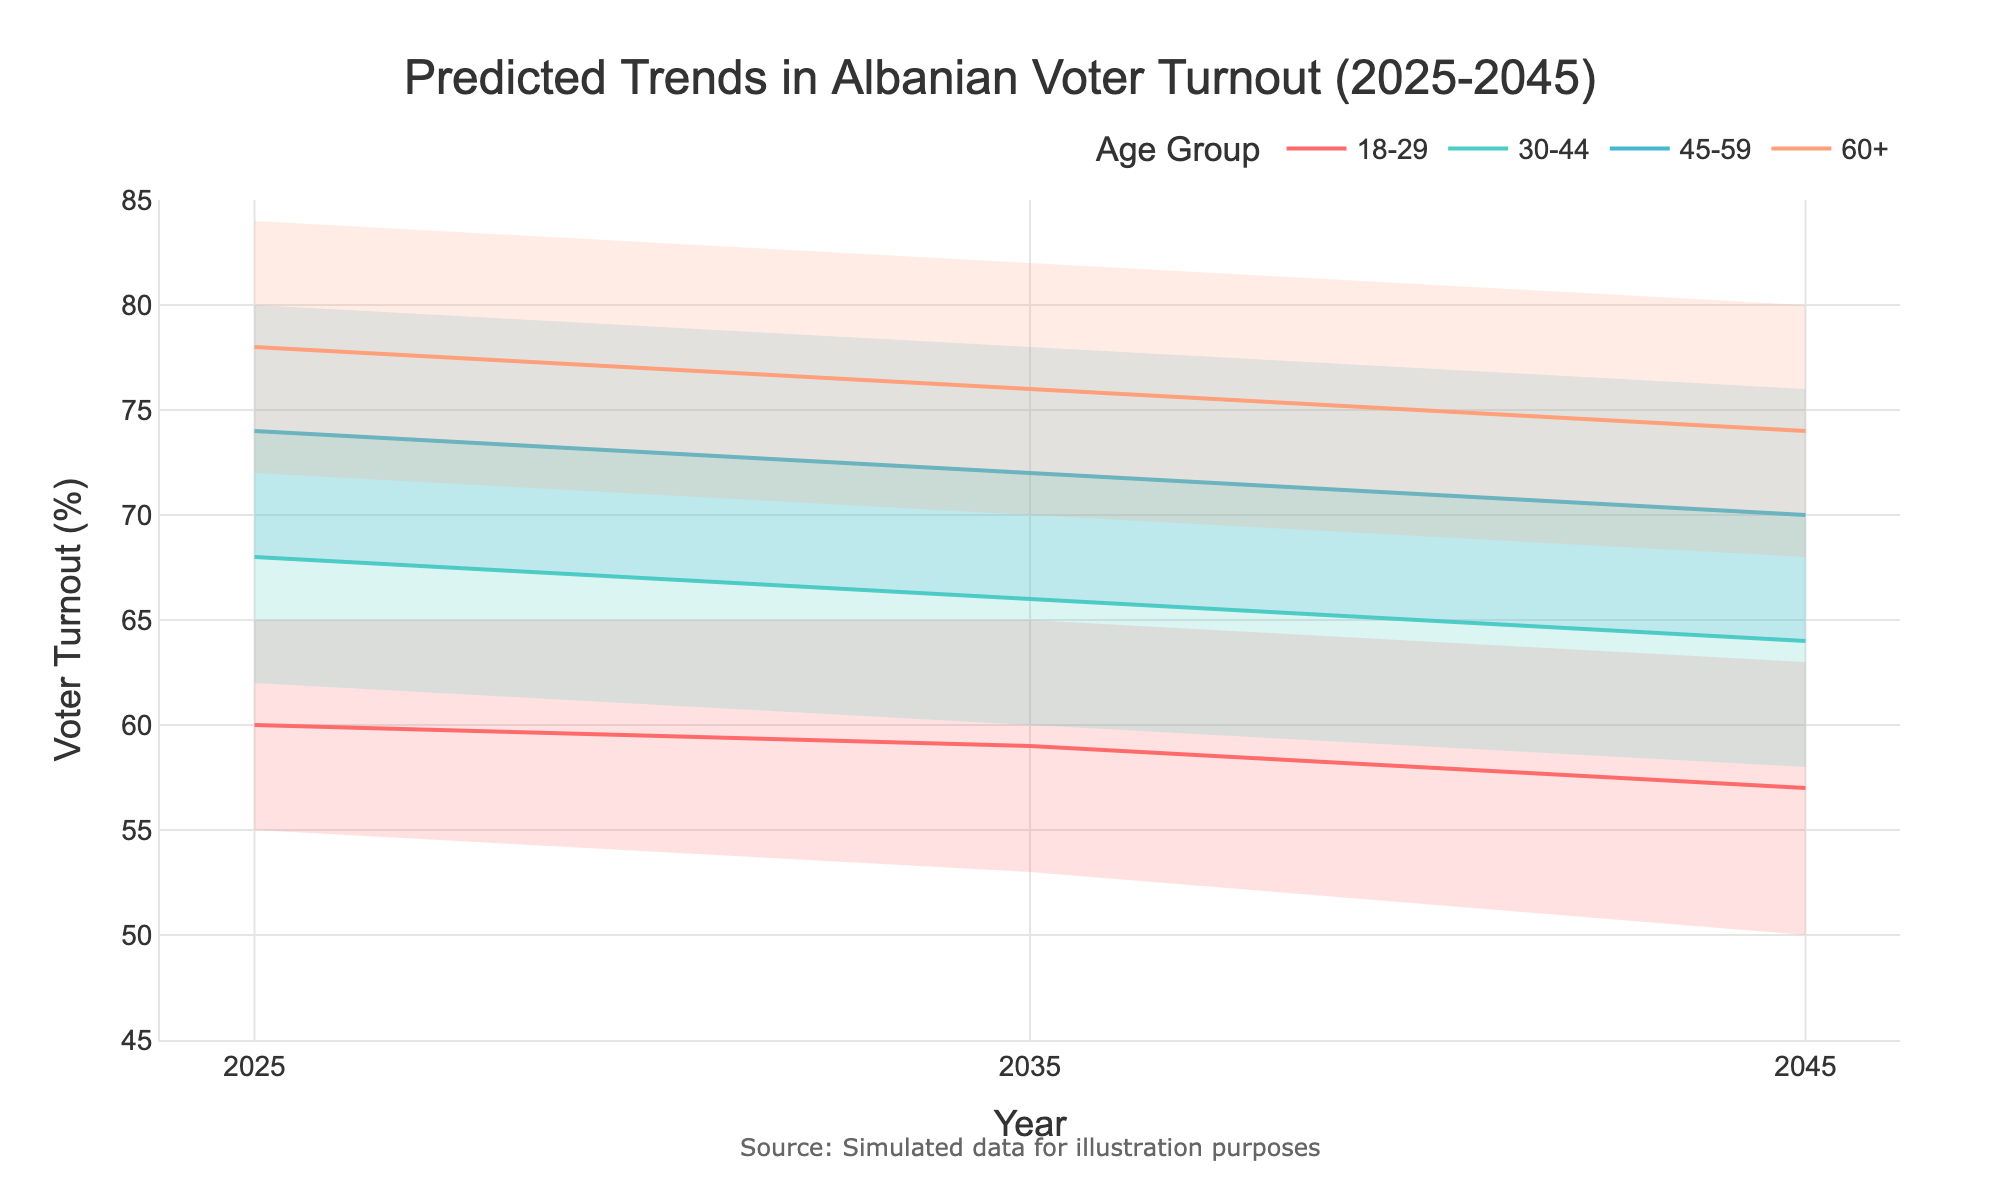What is the title of the figure? The title is located at the top center of the figure. The text reads 'Predicted Trends in Albanian Voter Turnout (2025-2045)'.
Answer: Predicted Trends in Albanian Voter Turnout (2025-2045) How many age groups are included in the figure? There are four age groups as indicated by the different colors and legends on the figure.
Answer: Four Which age group has the highest median voter turnout in 2025? The figure shows the median estimates for each age group along the y-axis. In 2025, the 60+ age group has the highest median turnout at 78%.
Answer: 60+ In which year is the predicted median voter turnout the lowest for the 18-29 age group? From 2025 to 2045, the median turnout for the 18-29 age group decreases. The lowest median value for this group is 57% in 2045.
Answer: 2045 What are the high and low voter turnout estimates for the 45-59 age group in 2035? By looking at the 2035 data for the 45-59 age group, the high estimate is 78% and the low estimate is 66%.
Answer: 78% high, 66% low What is the predicted median voter turnout for the 30-44 age group in 2035? The median estimate is represented by the solid line within each age group. For the 30-44 age group in 2035, the median voter turnout is 66%.
Answer: 66% By how much does the median voter turnout for the 60+ age group decrease from 2045 to 2025? In 2025, the median for the 60+ group is 78%. In 2045, it is 74%. The decrease is 78% - 74% = 4%.
Answer: 4% Which age group shows the smallest range between high and low estimates in 2045? The range is calculated by subtracting the low estimate from the high estimate for each age group in 2045. The smallest range is seen in the 60+ age group, which ranges from 80% to 68%, a difference of 12%.
Answer: 60+ How does the median voter turnout trend over time for the 18-29 age group? The 18-29 age group sees a decline over time. It starts at 60% in 2025, goes to 59% in 2035, and falls to 57% in 2045.
Answer: Declining Which age group will have the closest high and low voter turnout estimates in 2025? To determine this, we compare the ranges for each age group in 2025. The 60+ age group has the closest estimates with a range of 12% (84% - 72%).
Answer: 60+ 